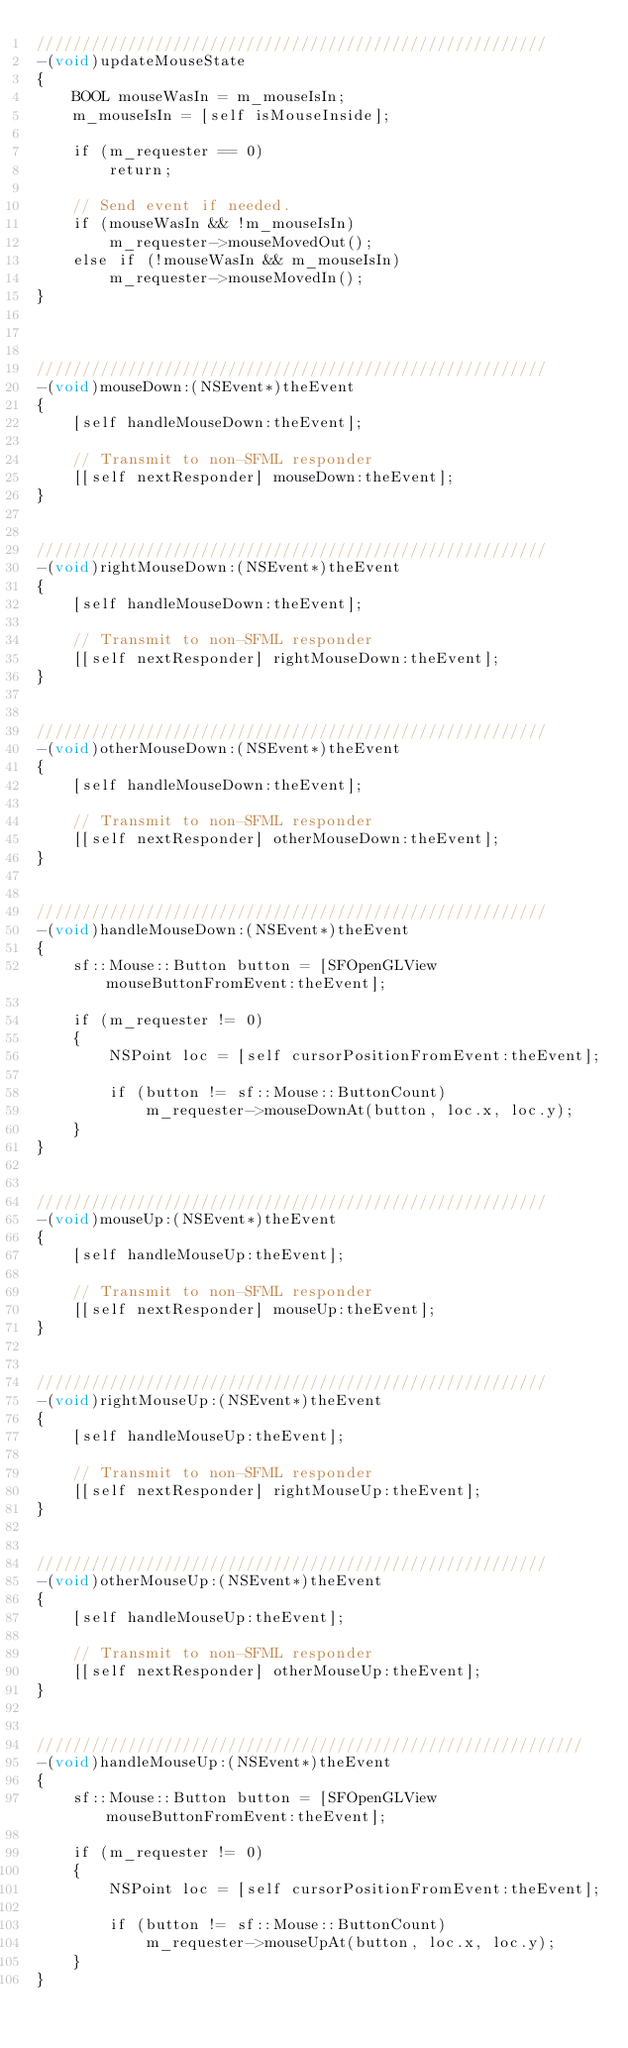Convert code to text. <code><loc_0><loc_0><loc_500><loc_500><_ObjectiveC_>////////////////////////////////////////////////////////
-(void)updateMouseState
{
    BOOL mouseWasIn = m_mouseIsIn;
    m_mouseIsIn = [self isMouseInside];

    if (m_requester == 0)
        return;

    // Send event if needed.
    if (mouseWasIn && !m_mouseIsIn)
        m_requester->mouseMovedOut();
    else if (!mouseWasIn && m_mouseIsIn)
        m_requester->mouseMovedIn();
}



////////////////////////////////////////////////////////
-(void)mouseDown:(NSEvent*)theEvent
{
    [self handleMouseDown:theEvent];

    // Transmit to non-SFML responder
    [[self nextResponder] mouseDown:theEvent];
}


////////////////////////////////////////////////////////
-(void)rightMouseDown:(NSEvent*)theEvent
{
    [self handleMouseDown:theEvent];

    // Transmit to non-SFML responder
    [[self nextResponder] rightMouseDown:theEvent];
}


////////////////////////////////////////////////////////
-(void)otherMouseDown:(NSEvent*)theEvent
{
    [self handleMouseDown:theEvent];

    // Transmit to non-SFML responder
    [[self nextResponder] otherMouseDown:theEvent];
}


////////////////////////////////////////////////////////
-(void)handleMouseDown:(NSEvent*)theEvent
{
    sf::Mouse::Button button = [SFOpenGLView mouseButtonFromEvent:theEvent];

    if (m_requester != 0)
    {
        NSPoint loc = [self cursorPositionFromEvent:theEvent];

        if (button != sf::Mouse::ButtonCount)
            m_requester->mouseDownAt(button, loc.x, loc.y);
    }
}


////////////////////////////////////////////////////////
-(void)mouseUp:(NSEvent*)theEvent
{
    [self handleMouseUp:theEvent];

    // Transmit to non-SFML responder
    [[self nextResponder] mouseUp:theEvent];
}


////////////////////////////////////////////////////////
-(void)rightMouseUp:(NSEvent*)theEvent
{
    [self handleMouseUp:theEvent];

    // Transmit to non-SFML responder
    [[self nextResponder] rightMouseUp:theEvent];
}


////////////////////////////////////////////////////////
-(void)otherMouseUp:(NSEvent*)theEvent
{
    [self handleMouseUp:theEvent];

    // Transmit to non-SFML responder
    [[self nextResponder] otherMouseUp:theEvent];
}


////////////////////////////////////////////////////////////
-(void)handleMouseUp:(NSEvent*)theEvent
{
    sf::Mouse::Button button = [SFOpenGLView mouseButtonFromEvent:theEvent];

    if (m_requester != 0)
    {
        NSPoint loc = [self cursorPositionFromEvent:theEvent];

        if (button != sf::Mouse::ButtonCount)
            m_requester->mouseUpAt(button, loc.x, loc.y);
    }
}

</code> 